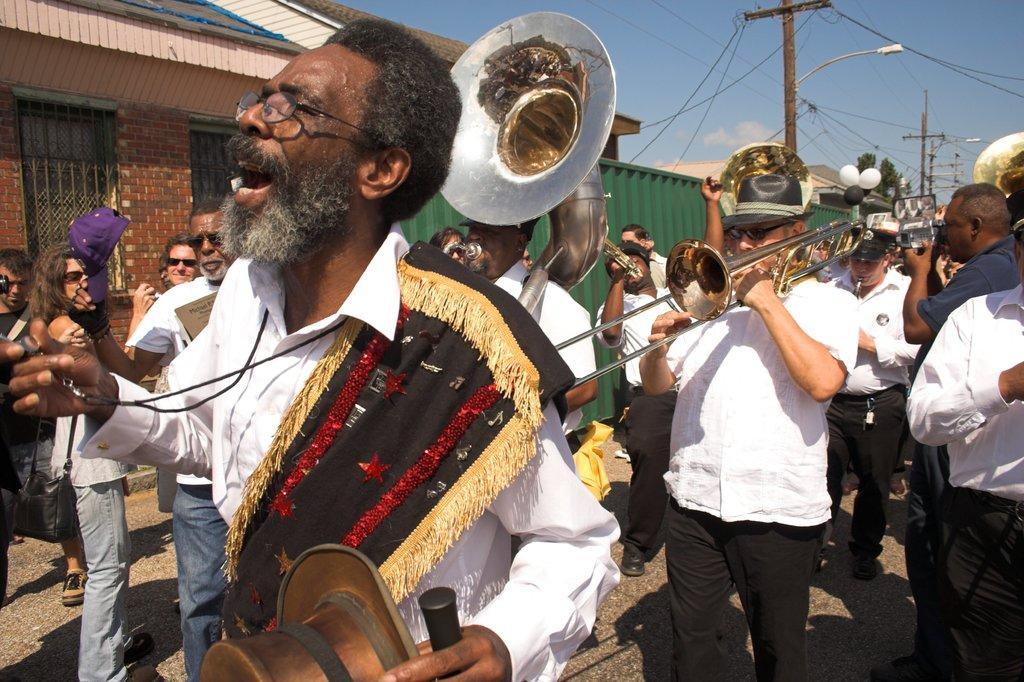Describe this image in one or two sentences. In this picture there are few people walking and playing musical instruments and this person is holding a hat, stick and a whistle and in the backdrop I can see there are few buildings and electric poles with cables attached. 